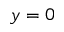<formula> <loc_0><loc_0><loc_500><loc_500>y = 0</formula> 